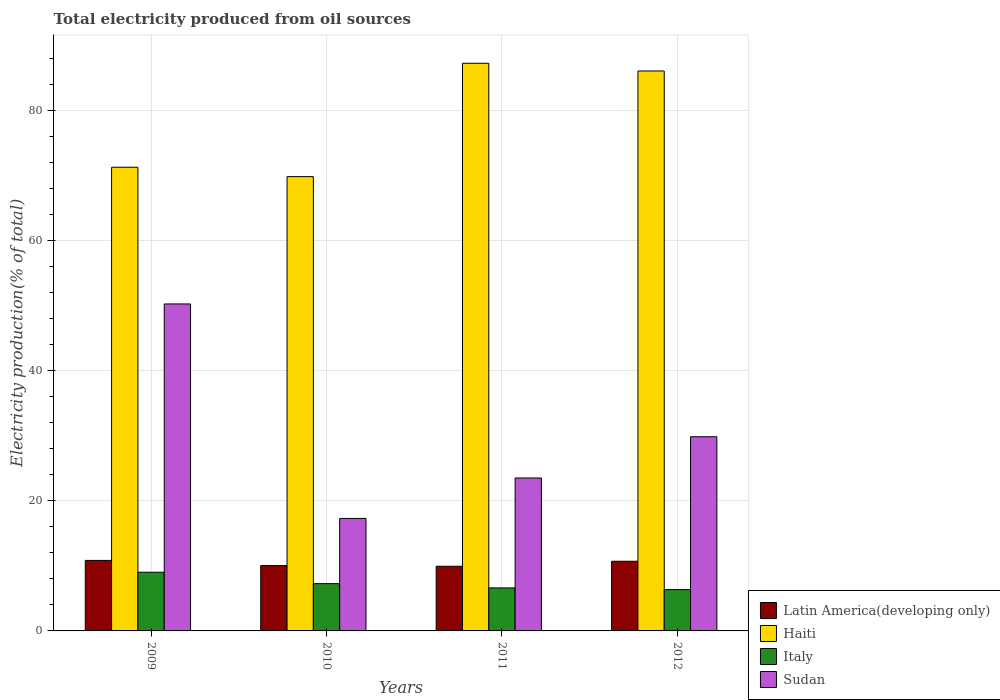How many different coloured bars are there?
Keep it short and to the point. 4. How many groups of bars are there?
Your answer should be compact. 4. How many bars are there on the 2nd tick from the left?
Offer a terse response. 4. What is the total electricity produced in Sudan in 2010?
Provide a succinct answer. 17.3. Across all years, what is the maximum total electricity produced in Haiti?
Your response must be concise. 87.27. Across all years, what is the minimum total electricity produced in Sudan?
Offer a terse response. 17.3. What is the total total electricity produced in Sudan in the graph?
Ensure brevity in your answer.  120.93. What is the difference between the total electricity produced in Italy in 2009 and that in 2012?
Give a very brief answer. 2.67. What is the difference between the total electricity produced in Haiti in 2011 and the total electricity produced in Italy in 2010?
Keep it short and to the point. 80.01. What is the average total electricity produced in Haiti per year?
Provide a succinct answer. 78.62. In the year 2010, what is the difference between the total electricity produced in Haiti and total electricity produced in Italy?
Provide a succinct answer. 62.58. What is the ratio of the total electricity produced in Sudan in 2009 to that in 2011?
Your answer should be compact. 2.14. What is the difference between the highest and the second highest total electricity produced in Latin America(developing only)?
Make the answer very short. 0.13. What is the difference between the highest and the lowest total electricity produced in Haiti?
Provide a succinct answer. 17.43. In how many years, is the total electricity produced in Latin America(developing only) greater than the average total electricity produced in Latin America(developing only) taken over all years?
Provide a succinct answer. 2. Is the sum of the total electricity produced in Latin America(developing only) in 2011 and 2012 greater than the maximum total electricity produced in Sudan across all years?
Provide a succinct answer. No. Is it the case that in every year, the sum of the total electricity produced in Haiti and total electricity produced in Sudan is greater than the sum of total electricity produced in Italy and total electricity produced in Latin America(developing only)?
Keep it short and to the point. Yes. What does the 2nd bar from the left in 2010 represents?
Ensure brevity in your answer.  Haiti. What does the 2nd bar from the right in 2010 represents?
Keep it short and to the point. Italy. Is it the case that in every year, the sum of the total electricity produced in Latin America(developing only) and total electricity produced in Haiti is greater than the total electricity produced in Italy?
Make the answer very short. Yes. How many years are there in the graph?
Make the answer very short. 4. What is the difference between two consecutive major ticks on the Y-axis?
Offer a very short reply. 20. Are the values on the major ticks of Y-axis written in scientific E-notation?
Your answer should be very brief. No. Does the graph contain any zero values?
Your answer should be very brief. No. Does the graph contain grids?
Your answer should be very brief. Yes. Where does the legend appear in the graph?
Give a very brief answer. Bottom right. What is the title of the graph?
Keep it short and to the point. Total electricity produced from oil sources. Does "Tunisia" appear as one of the legend labels in the graph?
Provide a succinct answer. No. What is the label or title of the X-axis?
Offer a very short reply. Years. What is the label or title of the Y-axis?
Provide a succinct answer. Electricity production(% of total). What is the Electricity production(% of total) in Latin America(developing only) in 2009?
Your response must be concise. 10.84. What is the Electricity production(% of total) of Haiti in 2009?
Offer a very short reply. 71.29. What is the Electricity production(% of total) of Italy in 2009?
Make the answer very short. 9.02. What is the Electricity production(% of total) of Sudan in 2009?
Offer a very short reply. 50.27. What is the Electricity production(% of total) of Latin America(developing only) in 2010?
Give a very brief answer. 10.05. What is the Electricity production(% of total) of Haiti in 2010?
Provide a succinct answer. 69.85. What is the Electricity production(% of total) of Italy in 2010?
Your answer should be very brief. 7.27. What is the Electricity production(% of total) in Sudan in 2010?
Offer a very short reply. 17.3. What is the Electricity production(% of total) of Latin America(developing only) in 2011?
Offer a terse response. 9.94. What is the Electricity production(% of total) in Haiti in 2011?
Keep it short and to the point. 87.27. What is the Electricity production(% of total) of Italy in 2011?
Offer a very short reply. 6.61. What is the Electricity production(% of total) of Sudan in 2011?
Offer a very short reply. 23.51. What is the Electricity production(% of total) in Latin America(developing only) in 2012?
Keep it short and to the point. 10.71. What is the Electricity production(% of total) of Haiti in 2012?
Provide a short and direct response. 86.09. What is the Electricity production(% of total) in Italy in 2012?
Offer a terse response. 6.35. What is the Electricity production(% of total) of Sudan in 2012?
Ensure brevity in your answer.  29.85. Across all years, what is the maximum Electricity production(% of total) of Latin America(developing only)?
Your answer should be compact. 10.84. Across all years, what is the maximum Electricity production(% of total) in Haiti?
Your answer should be compact. 87.27. Across all years, what is the maximum Electricity production(% of total) in Italy?
Offer a terse response. 9.02. Across all years, what is the maximum Electricity production(% of total) of Sudan?
Offer a very short reply. 50.27. Across all years, what is the minimum Electricity production(% of total) of Latin America(developing only)?
Give a very brief answer. 9.94. Across all years, what is the minimum Electricity production(% of total) of Haiti?
Keep it short and to the point. 69.85. Across all years, what is the minimum Electricity production(% of total) in Italy?
Provide a short and direct response. 6.35. Across all years, what is the minimum Electricity production(% of total) of Sudan?
Your answer should be very brief. 17.3. What is the total Electricity production(% of total) in Latin America(developing only) in the graph?
Provide a short and direct response. 41.54. What is the total Electricity production(% of total) of Haiti in the graph?
Your answer should be very brief. 314.5. What is the total Electricity production(% of total) of Italy in the graph?
Your response must be concise. 29.26. What is the total Electricity production(% of total) in Sudan in the graph?
Offer a terse response. 120.93. What is the difference between the Electricity production(% of total) of Latin America(developing only) in 2009 and that in 2010?
Ensure brevity in your answer.  0.79. What is the difference between the Electricity production(% of total) in Haiti in 2009 and that in 2010?
Give a very brief answer. 1.44. What is the difference between the Electricity production(% of total) of Italy in 2009 and that in 2010?
Your answer should be very brief. 1.76. What is the difference between the Electricity production(% of total) in Sudan in 2009 and that in 2010?
Offer a very short reply. 32.97. What is the difference between the Electricity production(% of total) in Latin America(developing only) in 2009 and that in 2011?
Your answer should be very brief. 0.9. What is the difference between the Electricity production(% of total) of Haiti in 2009 and that in 2011?
Make the answer very short. -15.98. What is the difference between the Electricity production(% of total) of Italy in 2009 and that in 2011?
Keep it short and to the point. 2.41. What is the difference between the Electricity production(% of total) in Sudan in 2009 and that in 2011?
Offer a very short reply. 26.76. What is the difference between the Electricity production(% of total) in Latin America(developing only) in 2009 and that in 2012?
Your answer should be very brief. 0.13. What is the difference between the Electricity production(% of total) in Haiti in 2009 and that in 2012?
Provide a succinct answer. -14.8. What is the difference between the Electricity production(% of total) in Italy in 2009 and that in 2012?
Your answer should be compact. 2.67. What is the difference between the Electricity production(% of total) of Sudan in 2009 and that in 2012?
Offer a terse response. 20.42. What is the difference between the Electricity production(% of total) in Latin America(developing only) in 2010 and that in 2011?
Give a very brief answer. 0.11. What is the difference between the Electricity production(% of total) of Haiti in 2010 and that in 2011?
Your response must be concise. -17.43. What is the difference between the Electricity production(% of total) in Italy in 2010 and that in 2011?
Provide a succinct answer. 0.65. What is the difference between the Electricity production(% of total) in Sudan in 2010 and that in 2011?
Keep it short and to the point. -6.22. What is the difference between the Electricity production(% of total) in Latin America(developing only) in 2010 and that in 2012?
Offer a terse response. -0.67. What is the difference between the Electricity production(% of total) of Haiti in 2010 and that in 2012?
Your answer should be compact. -16.24. What is the difference between the Electricity production(% of total) of Italy in 2010 and that in 2012?
Your answer should be very brief. 0.91. What is the difference between the Electricity production(% of total) of Sudan in 2010 and that in 2012?
Keep it short and to the point. -12.56. What is the difference between the Electricity production(% of total) in Latin America(developing only) in 2011 and that in 2012?
Provide a succinct answer. -0.77. What is the difference between the Electricity production(% of total) in Haiti in 2011 and that in 2012?
Keep it short and to the point. 1.19. What is the difference between the Electricity production(% of total) of Italy in 2011 and that in 2012?
Make the answer very short. 0.26. What is the difference between the Electricity production(% of total) in Sudan in 2011 and that in 2012?
Give a very brief answer. -6.34. What is the difference between the Electricity production(% of total) in Latin America(developing only) in 2009 and the Electricity production(% of total) in Haiti in 2010?
Offer a terse response. -59.01. What is the difference between the Electricity production(% of total) in Latin America(developing only) in 2009 and the Electricity production(% of total) in Italy in 2010?
Offer a very short reply. 3.57. What is the difference between the Electricity production(% of total) of Latin America(developing only) in 2009 and the Electricity production(% of total) of Sudan in 2010?
Make the answer very short. -6.46. What is the difference between the Electricity production(% of total) of Haiti in 2009 and the Electricity production(% of total) of Italy in 2010?
Offer a very short reply. 64.02. What is the difference between the Electricity production(% of total) in Haiti in 2009 and the Electricity production(% of total) in Sudan in 2010?
Provide a succinct answer. 53.99. What is the difference between the Electricity production(% of total) of Italy in 2009 and the Electricity production(% of total) of Sudan in 2010?
Ensure brevity in your answer.  -8.27. What is the difference between the Electricity production(% of total) in Latin America(developing only) in 2009 and the Electricity production(% of total) in Haiti in 2011?
Make the answer very short. -76.43. What is the difference between the Electricity production(% of total) in Latin America(developing only) in 2009 and the Electricity production(% of total) in Italy in 2011?
Give a very brief answer. 4.23. What is the difference between the Electricity production(% of total) of Latin America(developing only) in 2009 and the Electricity production(% of total) of Sudan in 2011?
Provide a succinct answer. -12.67. What is the difference between the Electricity production(% of total) in Haiti in 2009 and the Electricity production(% of total) in Italy in 2011?
Ensure brevity in your answer.  64.68. What is the difference between the Electricity production(% of total) of Haiti in 2009 and the Electricity production(% of total) of Sudan in 2011?
Provide a succinct answer. 47.78. What is the difference between the Electricity production(% of total) in Italy in 2009 and the Electricity production(% of total) in Sudan in 2011?
Offer a terse response. -14.49. What is the difference between the Electricity production(% of total) in Latin America(developing only) in 2009 and the Electricity production(% of total) in Haiti in 2012?
Keep it short and to the point. -75.25. What is the difference between the Electricity production(% of total) in Latin America(developing only) in 2009 and the Electricity production(% of total) in Italy in 2012?
Ensure brevity in your answer.  4.49. What is the difference between the Electricity production(% of total) in Latin America(developing only) in 2009 and the Electricity production(% of total) in Sudan in 2012?
Your response must be concise. -19.01. What is the difference between the Electricity production(% of total) of Haiti in 2009 and the Electricity production(% of total) of Italy in 2012?
Give a very brief answer. 64.94. What is the difference between the Electricity production(% of total) of Haiti in 2009 and the Electricity production(% of total) of Sudan in 2012?
Keep it short and to the point. 41.44. What is the difference between the Electricity production(% of total) in Italy in 2009 and the Electricity production(% of total) in Sudan in 2012?
Offer a very short reply. -20.83. What is the difference between the Electricity production(% of total) in Latin America(developing only) in 2010 and the Electricity production(% of total) in Haiti in 2011?
Provide a succinct answer. -77.23. What is the difference between the Electricity production(% of total) of Latin America(developing only) in 2010 and the Electricity production(% of total) of Italy in 2011?
Ensure brevity in your answer.  3.43. What is the difference between the Electricity production(% of total) in Latin America(developing only) in 2010 and the Electricity production(% of total) in Sudan in 2011?
Offer a very short reply. -13.47. What is the difference between the Electricity production(% of total) in Haiti in 2010 and the Electricity production(% of total) in Italy in 2011?
Make the answer very short. 63.23. What is the difference between the Electricity production(% of total) of Haiti in 2010 and the Electricity production(% of total) of Sudan in 2011?
Offer a terse response. 46.33. What is the difference between the Electricity production(% of total) of Italy in 2010 and the Electricity production(% of total) of Sudan in 2011?
Your answer should be compact. -16.25. What is the difference between the Electricity production(% of total) of Latin America(developing only) in 2010 and the Electricity production(% of total) of Haiti in 2012?
Provide a short and direct response. -76.04. What is the difference between the Electricity production(% of total) of Latin America(developing only) in 2010 and the Electricity production(% of total) of Italy in 2012?
Your answer should be compact. 3.69. What is the difference between the Electricity production(% of total) in Latin America(developing only) in 2010 and the Electricity production(% of total) in Sudan in 2012?
Your answer should be very brief. -19.81. What is the difference between the Electricity production(% of total) in Haiti in 2010 and the Electricity production(% of total) in Italy in 2012?
Ensure brevity in your answer.  63.49. What is the difference between the Electricity production(% of total) of Haiti in 2010 and the Electricity production(% of total) of Sudan in 2012?
Make the answer very short. 39.99. What is the difference between the Electricity production(% of total) of Italy in 2010 and the Electricity production(% of total) of Sudan in 2012?
Keep it short and to the point. -22.59. What is the difference between the Electricity production(% of total) in Latin America(developing only) in 2011 and the Electricity production(% of total) in Haiti in 2012?
Your answer should be compact. -76.15. What is the difference between the Electricity production(% of total) in Latin America(developing only) in 2011 and the Electricity production(% of total) in Italy in 2012?
Your response must be concise. 3.59. What is the difference between the Electricity production(% of total) of Latin America(developing only) in 2011 and the Electricity production(% of total) of Sudan in 2012?
Your answer should be very brief. -19.91. What is the difference between the Electricity production(% of total) of Haiti in 2011 and the Electricity production(% of total) of Italy in 2012?
Your answer should be very brief. 80.92. What is the difference between the Electricity production(% of total) of Haiti in 2011 and the Electricity production(% of total) of Sudan in 2012?
Your answer should be very brief. 57.42. What is the difference between the Electricity production(% of total) in Italy in 2011 and the Electricity production(% of total) in Sudan in 2012?
Offer a very short reply. -23.24. What is the average Electricity production(% of total) in Latin America(developing only) per year?
Make the answer very short. 10.39. What is the average Electricity production(% of total) in Haiti per year?
Ensure brevity in your answer.  78.62. What is the average Electricity production(% of total) of Italy per year?
Give a very brief answer. 7.31. What is the average Electricity production(% of total) in Sudan per year?
Your response must be concise. 30.23. In the year 2009, what is the difference between the Electricity production(% of total) of Latin America(developing only) and Electricity production(% of total) of Haiti?
Keep it short and to the point. -60.45. In the year 2009, what is the difference between the Electricity production(% of total) in Latin America(developing only) and Electricity production(% of total) in Italy?
Your answer should be very brief. 1.82. In the year 2009, what is the difference between the Electricity production(% of total) of Latin America(developing only) and Electricity production(% of total) of Sudan?
Keep it short and to the point. -39.43. In the year 2009, what is the difference between the Electricity production(% of total) in Haiti and Electricity production(% of total) in Italy?
Give a very brief answer. 62.27. In the year 2009, what is the difference between the Electricity production(% of total) of Haiti and Electricity production(% of total) of Sudan?
Provide a succinct answer. 21.02. In the year 2009, what is the difference between the Electricity production(% of total) of Italy and Electricity production(% of total) of Sudan?
Provide a succinct answer. -41.25. In the year 2010, what is the difference between the Electricity production(% of total) of Latin America(developing only) and Electricity production(% of total) of Haiti?
Offer a terse response. -59.8. In the year 2010, what is the difference between the Electricity production(% of total) of Latin America(developing only) and Electricity production(% of total) of Italy?
Provide a short and direct response. 2.78. In the year 2010, what is the difference between the Electricity production(% of total) of Latin America(developing only) and Electricity production(% of total) of Sudan?
Make the answer very short. -7.25. In the year 2010, what is the difference between the Electricity production(% of total) in Haiti and Electricity production(% of total) in Italy?
Give a very brief answer. 62.58. In the year 2010, what is the difference between the Electricity production(% of total) of Haiti and Electricity production(% of total) of Sudan?
Offer a terse response. 52.55. In the year 2010, what is the difference between the Electricity production(% of total) of Italy and Electricity production(% of total) of Sudan?
Provide a short and direct response. -10.03. In the year 2011, what is the difference between the Electricity production(% of total) in Latin America(developing only) and Electricity production(% of total) in Haiti?
Your response must be concise. -77.33. In the year 2011, what is the difference between the Electricity production(% of total) in Latin America(developing only) and Electricity production(% of total) in Italy?
Keep it short and to the point. 3.33. In the year 2011, what is the difference between the Electricity production(% of total) of Latin America(developing only) and Electricity production(% of total) of Sudan?
Your response must be concise. -13.57. In the year 2011, what is the difference between the Electricity production(% of total) in Haiti and Electricity production(% of total) in Italy?
Provide a succinct answer. 80.66. In the year 2011, what is the difference between the Electricity production(% of total) of Haiti and Electricity production(% of total) of Sudan?
Provide a short and direct response. 63.76. In the year 2011, what is the difference between the Electricity production(% of total) in Italy and Electricity production(% of total) in Sudan?
Give a very brief answer. -16.9. In the year 2012, what is the difference between the Electricity production(% of total) of Latin America(developing only) and Electricity production(% of total) of Haiti?
Provide a short and direct response. -75.37. In the year 2012, what is the difference between the Electricity production(% of total) of Latin America(developing only) and Electricity production(% of total) of Italy?
Your answer should be compact. 4.36. In the year 2012, what is the difference between the Electricity production(% of total) of Latin America(developing only) and Electricity production(% of total) of Sudan?
Make the answer very short. -19.14. In the year 2012, what is the difference between the Electricity production(% of total) of Haiti and Electricity production(% of total) of Italy?
Give a very brief answer. 79.73. In the year 2012, what is the difference between the Electricity production(% of total) in Haiti and Electricity production(% of total) in Sudan?
Provide a short and direct response. 56.23. In the year 2012, what is the difference between the Electricity production(% of total) of Italy and Electricity production(% of total) of Sudan?
Your response must be concise. -23.5. What is the ratio of the Electricity production(% of total) of Latin America(developing only) in 2009 to that in 2010?
Offer a terse response. 1.08. What is the ratio of the Electricity production(% of total) in Haiti in 2009 to that in 2010?
Provide a succinct answer. 1.02. What is the ratio of the Electricity production(% of total) of Italy in 2009 to that in 2010?
Provide a short and direct response. 1.24. What is the ratio of the Electricity production(% of total) in Sudan in 2009 to that in 2010?
Provide a short and direct response. 2.91. What is the ratio of the Electricity production(% of total) in Latin America(developing only) in 2009 to that in 2011?
Your answer should be very brief. 1.09. What is the ratio of the Electricity production(% of total) of Haiti in 2009 to that in 2011?
Provide a short and direct response. 0.82. What is the ratio of the Electricity production(% of total) in Italy in 2009 to that in 2011?
Your answer should be very brief. 1.36. What is the ratio of the Electricity production(% of total) in Sudan in 2009 to that in 2011?
Make the answer very short. 2.14. What is the ratio of the Electricity production(% of total) of Latin America(developing only) in 2009 to that in 2012?
Your response must be concise. 1.01. What is the ratio of the Electricity production(% of total) in Haiti in 2009 to that in 2012?
Offer a terse response. 0.83. What is the ratio of the Electricity production(% of total) in Italy in 2009 to that in 2012?
Your response must be concise. 1.42. What is the ratio of the Electricity production(% of total) of Sudan in 2009 to that in 2012?
Provide a short and direct response. 1.68. What is the ratio of the Electricity production(% of total) in Latin America(developing only) in 2010 to that in 2011?
Provide a short and direct response. 1.01. What is the ratio of the Electricity production(% of total) in Haiti in 2010 to that in 2011?
Offer a very short reply. 0.8. What is the ratio of the Electricity production(% of total) in Italy in 2010 to that in 2011?
Make the answer very short. 1.1. What is the ratio of the Electricity production(% of total) of Sudan in 2010 to that in 2011?
Keep it short and to the point. 0.74. What is the ratio of the Electricity production(% of total) in Latin America(developing only) in 2010 to that in 2012?
Provide a short and direct response. 0.94. What is the ratio of the Electricity production(% of total) in Haiti in 2010 to that in 2012?
Give a very brief answer. 0.81. What is the ratio of the Electricity production(% of total) of Italy in 2010 to that in 2012?
Give a very brief answer. 1.14. What is the ratio of the Electricity production(% of total) in Sudan in 2010 to that in 2012?
Offer a terse response. 0.58. What is the ratio of the Electricity production(% of total) of Latin America(developing only) in 2011 to that in 2012?
Offer a terse response. 0.93. What is the ratio of the Electricity production(% of total) in Haiti in 2011 to that in 2012?
Your answer should be compact. 1.01. What is the ratio of the Electricity production(% of total) in Italy in 2011 to that in 2012?
Provide a succinct answer. 1.04. What is the ratio of the Electricity production(% of total) of Sudan in 2011 to that in 2012?
Provide a short and direct response. 0.79. What is the difference between the highest and the second highest Electricity production(% of total) of Latin America(developing only)?
Your response must be concise. 0.13. What is the difference between the highest and the second highest Electricity production(% of total) of Haiti?
Offer a very short reply. 1.19. What is the difference between the highest and the second highest Electricity production(% of total) of Italy?
Make the answer very short. 1.76. What is the difference between the highest and the second highest Electricity production(% of total) in Sudan?
Make the answer very short. 20.42. What is the difference between the highest and the lowest Electricity production(% of total) of Latin America(developing only)?
Offer a terse response. 0.9. What is the difference between the highest and the lowest Electricity production(% of total) in Haiti?
Provide a short and direct response. 17.43. What is the difference between the highest and the lowest Electricity production(% of total) in Italy?
Ensure brevity in your answer.  2.67. What is the difference between the highest and the lowest Electricity production(% of total) in Sudan?
Provide a succinct answer. 32.97. 